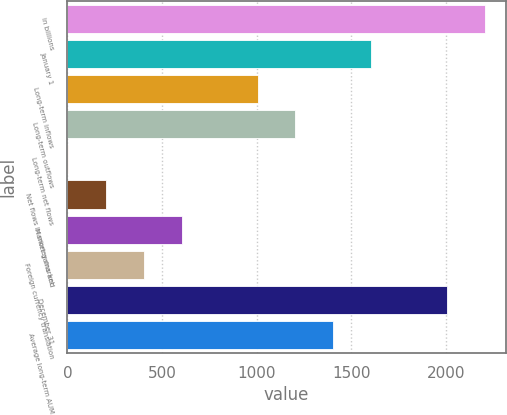Convert chart to OTSL. <chart><loc_0><loc_0><loc_500><loc_500><bar_chart><fcel>in billions<fcel>January 1<fcel>Long-term inflows<fcel>Long-term outflows<fcel>Long-term net flows<fcel>Net flows in money market<fcel>Market gains and<fcel>Foreign currency translation<fcel>December 31<fcel>Average long-term AUM<nl><fcel>2207.36<fcel>1606.28<fcel>1005.2<fcel>1205.56<fcel>3.4<fcel>203.76<fcel>604.48<fcel>404.12<fcel>2007<fcel>1405.92<nl></chart> 